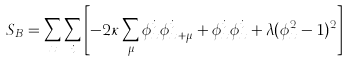Convert formula to latex. <formula><loc_0><loc_0><loc_500><loc_500>S _ { B } = \sum _ { x } \sum _ { i } \left [ - 2 \kappa \sum _ { \mu } \phi _ { x } ^ { i } \phi _ { x + \mu } ^ { i } + \phi _ { x } ^ { i } \phi _ { x } ^ { i } + \lambda ( \phi _ { x } ^ { 2 } - 1 ) ^ { 2 } \right ]</formula> 